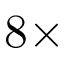Convert formula to latex. <formula><loc_0><loc_0><loc_500><loc_500>8 \times</formula> 